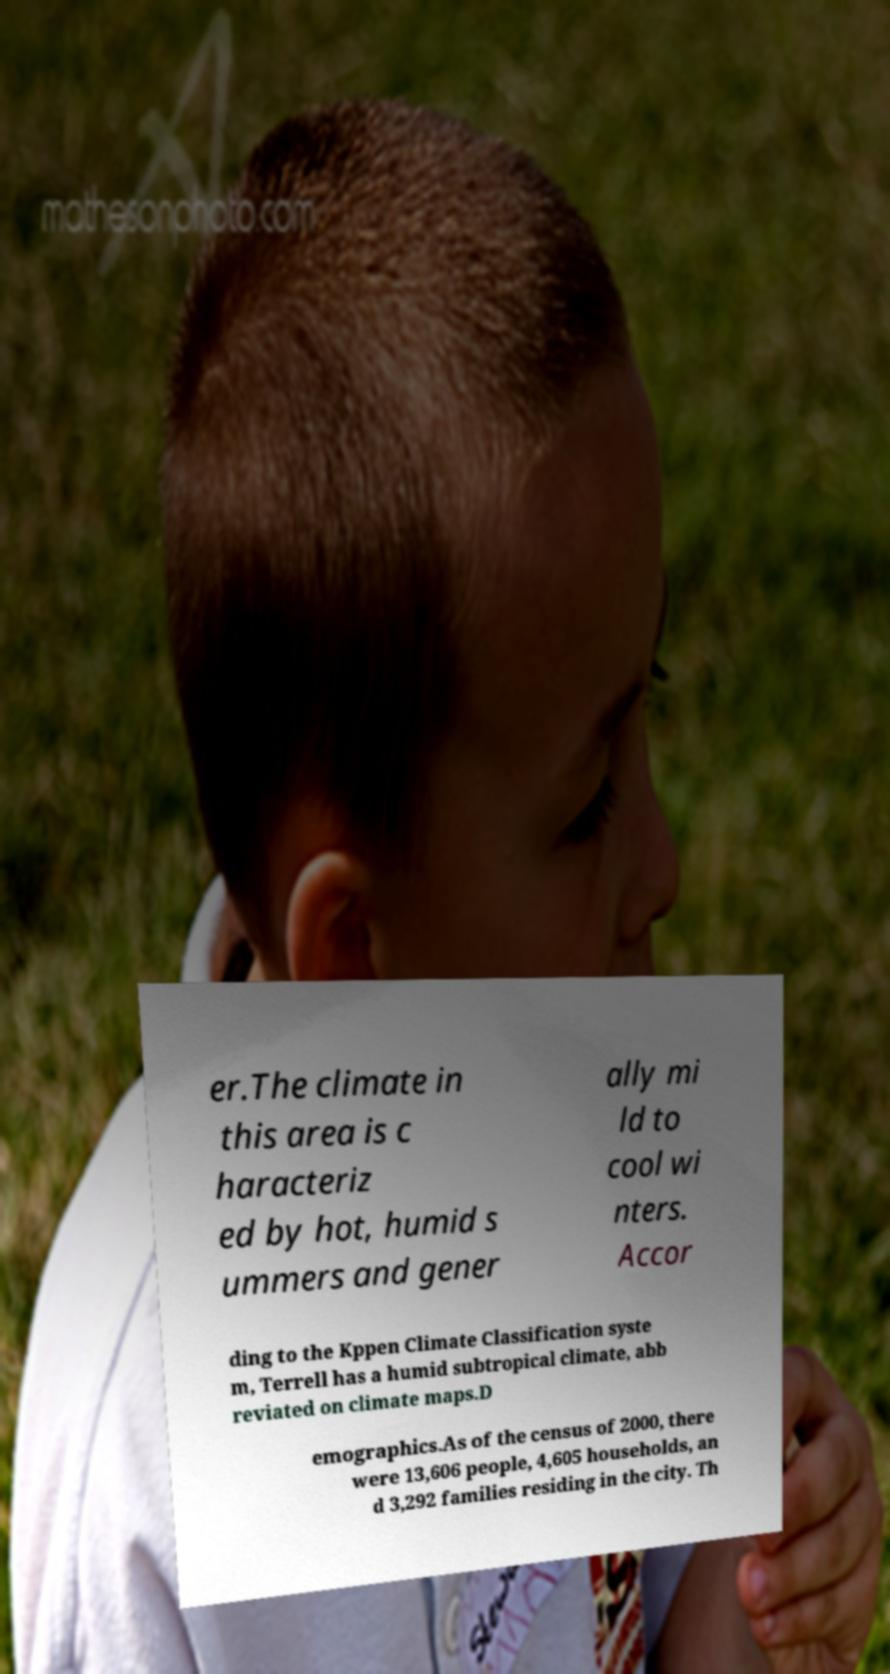I need the written content from this picture converted into text. Can you do that? er.The climate in this area is c haracteriz ed by hot, humid s ummers and gener ally mi ld to cool wi nters. Accor ding to the Kppen Climate Classification syste m, Terrell has a humid subtropical climate, abb reviated on climate maps.D emographics.As of the census of 2000, there were 13,606 people, 4,605 households, an d 3,292 families residing in the city. Th 